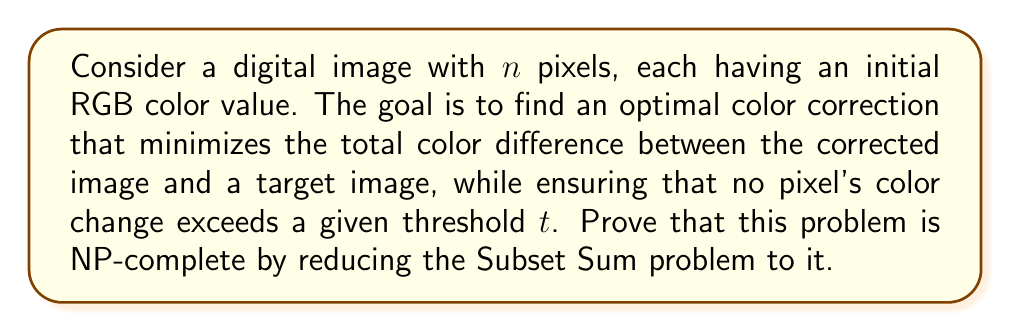Provide a solution to this math problem. To prove that the optimal color correction problem is NP-complete, we need to show that it is in NP and that it is NP-hard. We'll focus on the NP-hardness proof by reducing the Subset Sum problem to our color correction problem.

1. First, let's define the Subset Sum problem:
   Given a set of integers $S = \{s_1, s_2, ..., s_m\}$ and a target sum $T$, determine if there exists a subset of $S$ whose elements sum to $T$.

2. We'll construct a reduction from Subset Sum to our color correction problem:
   a. Create an image with $m+1$ pixels, where $m$ is the number of integers in set $S$.
   b. Set the initial color of each pixel $i$ (1 ≤ i ≤ m) to $(0, 0, 0)$.
   c. Set the target color of each pixel $i$ to $(s_i, 0, 0)$.
   d. Set the initial color of pixel $m+1$ to $(0, 0, 0)$ and its target color to $(T, 0, 0)$.
   e. Set the threshold $t = \max(s_1, s_2, ..., s_m, T)$.

3. Now, we need to show that a solution to the Subset Sum problem exists if and only if there exists a color correction that achieves a total color difference of 0.

4. If there exists a subset of $S$ that sums to $T$:
   - For each $s_i$ in the subset, change the corresponding pixel's color to $(s_i, 0, 0)$.
   - Leave the colors of the other pixels unchanged.
   - The sum of the changed pixels will equal $T$, matching the target color of pixel $m+1$.
   - This results in a total color difference of 0, and no pixel change exceeds the threshold $t$.

5. Conversely, if there exists a color correction with a total color difference of 0:
   - The pixels that have been changed to match their target colors correspond to a subset of $S$.
   - The sum of these changed pixels must equal $T$ to match the target color of pixel $m+1$.
   - Therefore, this subset of $S$ sums to $T$, solving the Subset Sum problem.

6. The reduction is polynomial-time computable, as we create an image with $m+1$ pixels and set their initial and target colors based on the input of the Subset Sum problem.

7. Since the Subset Sum problem is NP-complete and we have shown a polynomial-time reduction to the color correction problem, we can conclude that the color correction problem is NP-hard.

8. The problem is in NP because a solution can be verified in polynomial time by checking if the total color difference is minimized and if no pixel's color change exceeds the threshold.

Therefore, the optimal color correction problem, as described, is NP-complete.
Answer: The optimal color correction problem, as described in the question, is NP-complete. This is proven by showing that the problem is in NP and by reducing the known NP-complete Subset Sum problem to it in polynomial time. 